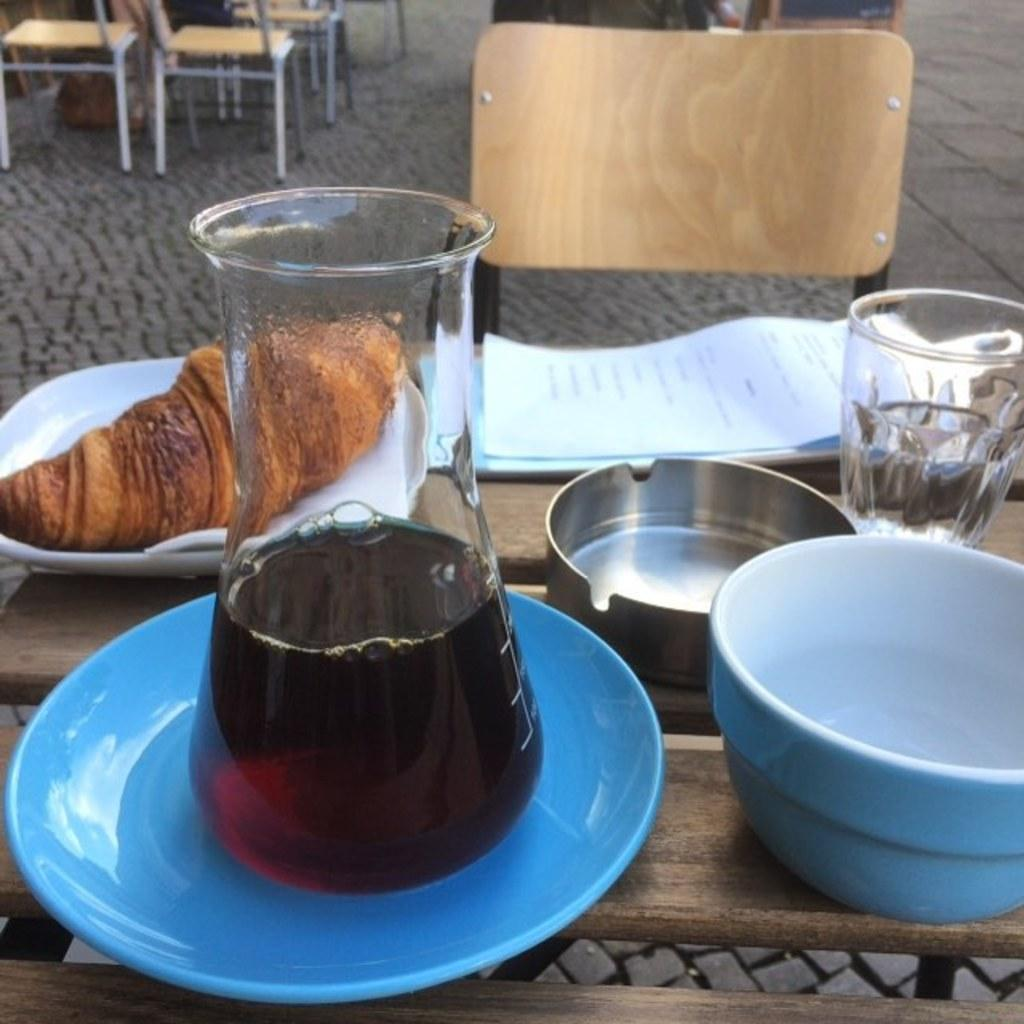What type of containers are visible in the image? There are bowls and glasses in the image. What can be found on the plates in the image? There are food items on plates in the image. Where is the jar located in the image? The jar is placed on a table in the image. What is present in the background of the image? There is a paper and chairs in the background of the image. How many bushes are visible in the image? There are no bushes present in the image. What type of footwear is being worn by the people in the image? There are no people visible in the image, so it is impossible to determine what type of footwear they might be wearing. 